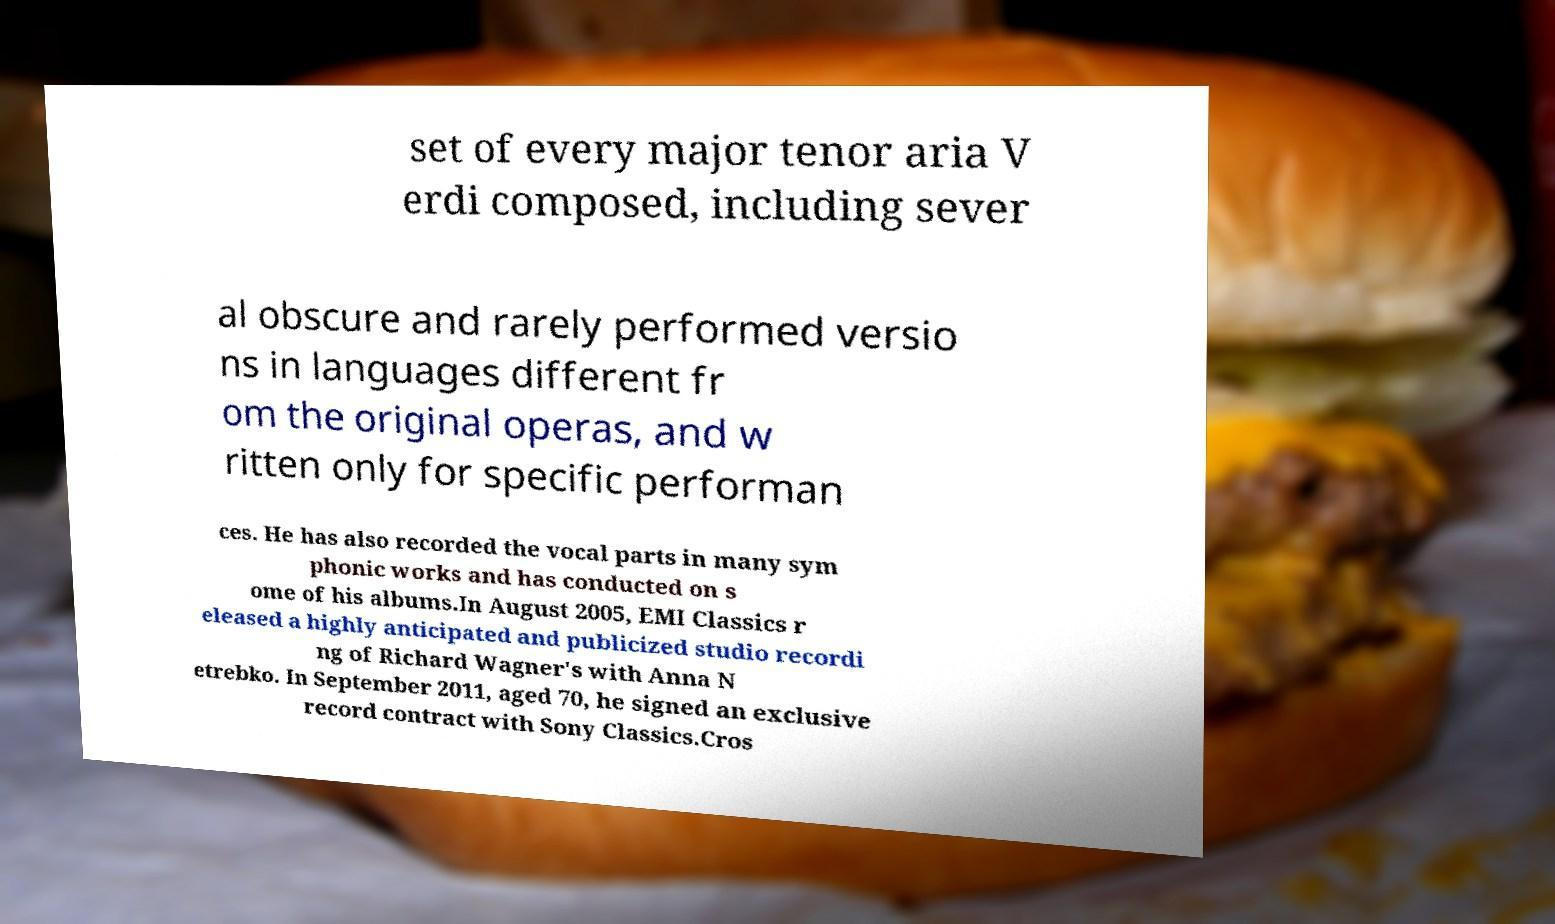Can you read and provide the text displayed in the image?This photo seems to have some interesting text. Can you extract and type it out for me? set of every major tenor aria V erdi composed, including sever al obscure and rarely performed versio ns in languages different fr om the original operas, and w ritten only for specific performan ces. He has also recorded the vocal parts in many sym phonic works and has conducted on s ome of his albums.In August 2005, EMI Classics r eleased a highly anticipated and publicized studio recordi ng of Richard Wagner's with Anna N etrebko. In September 2011, aged 70, he signed an exclusive record contract with Sony Classics.Cros 